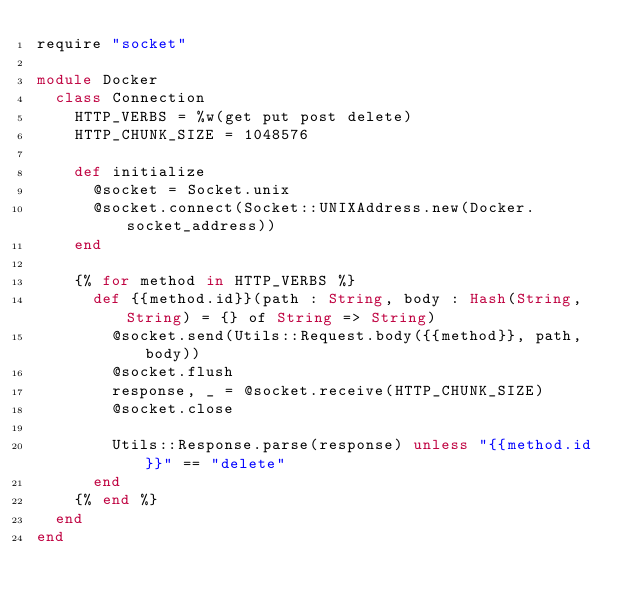Convert code to text. <code><loc_0><loc_0><loc_500><loc_500><_Crystal_>require "socket"

module Docker
  class Connection
    HTTP_VERBS = %w(get put post delete)
    HTTP_CHUNK_SIZE = 1048576

    def initialize
      @socket = Socket.unix
      @socket.connect(Socket::UNIXAddress.new(Docker.socket_address))
    end

    {% for method in HTTP_VERBS %}
      def {{method.id}}(path : String, body : Hash(String, String) = {} of String => String)
        @socket.send(Utils::Request.body({{method}}, path, body))
        @socket.flush
        response, _ = @socket.receive(HTTP_CHUNK_SIZE)
        @socket.close
  
        Utils::Response.parse(response) unless "{{method.id}}" == "delete"
      end
    {% end %}
  end
end
</code> 